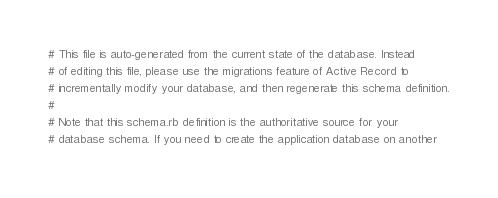Convert code to text. <code><loc_0><loc_0><loc_500><loc_500><_Ruby_># This file is auto-generated from the current state of the database. Instead
# of editing this file, please use the migrations feature of Active Record to
# incrementally modify your database, and then regenerate this schema definition.
#
# Note that this schema.rb definition is the authoritative source for your
# database schema. If you need to create the application database on another</code> 